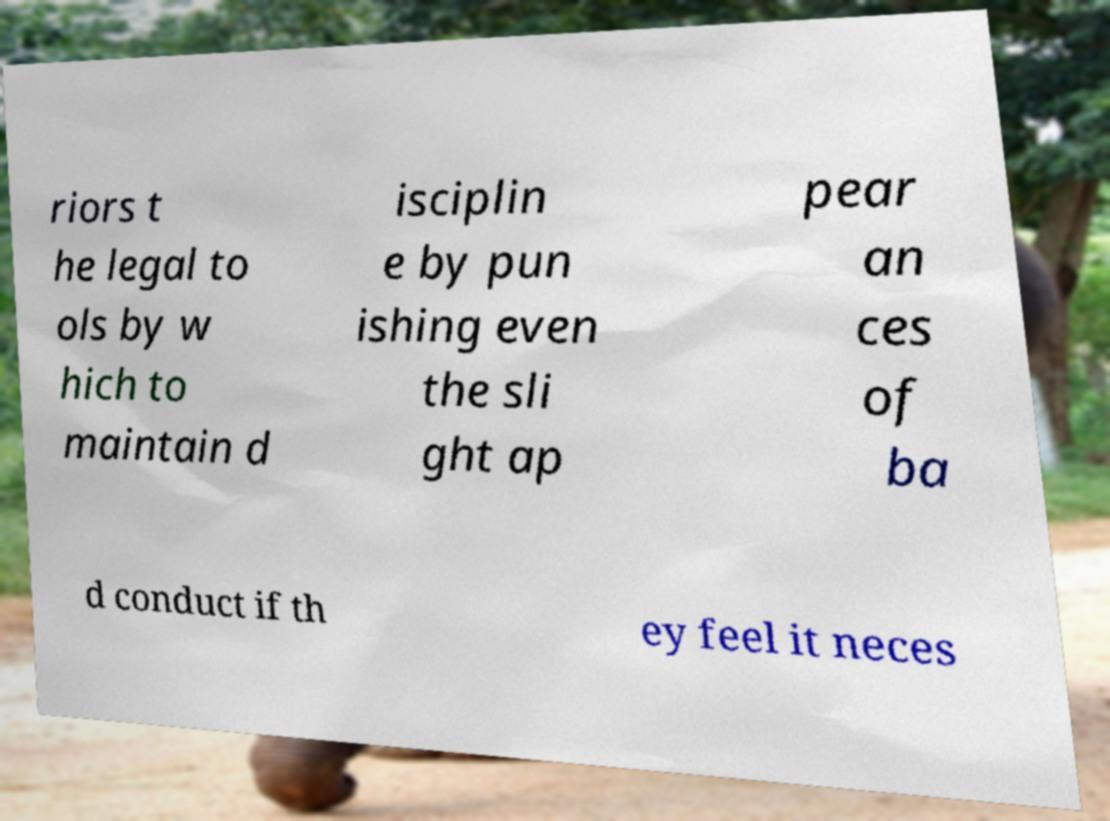For documentation purposes, I need the text within this image transcribed. Could you provide that? riors t he legal to ols by w hich to maintain d isciplin e by pun ishing even the sli ght ap pear an ces of ba d conduct if th ey feel it neces 